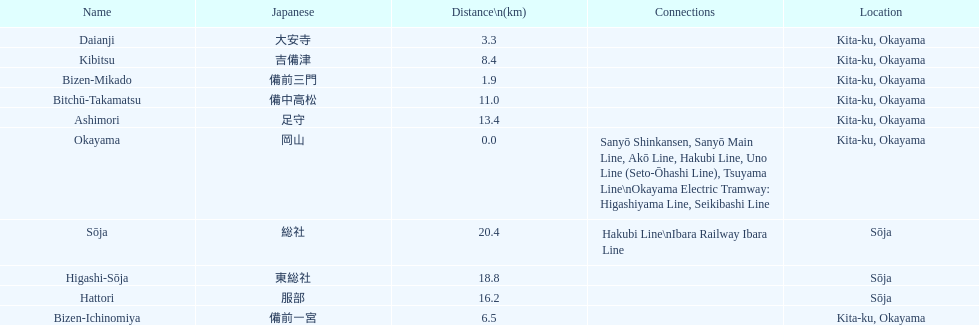Name only the stations that have connections to other lines. Okayama, Sōja. 